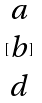<formula> <loc_0><loc_0><loc_500><loc_500>[ \begin{matrix} a \\ b \\ d \end{matrix} ]</formula> 